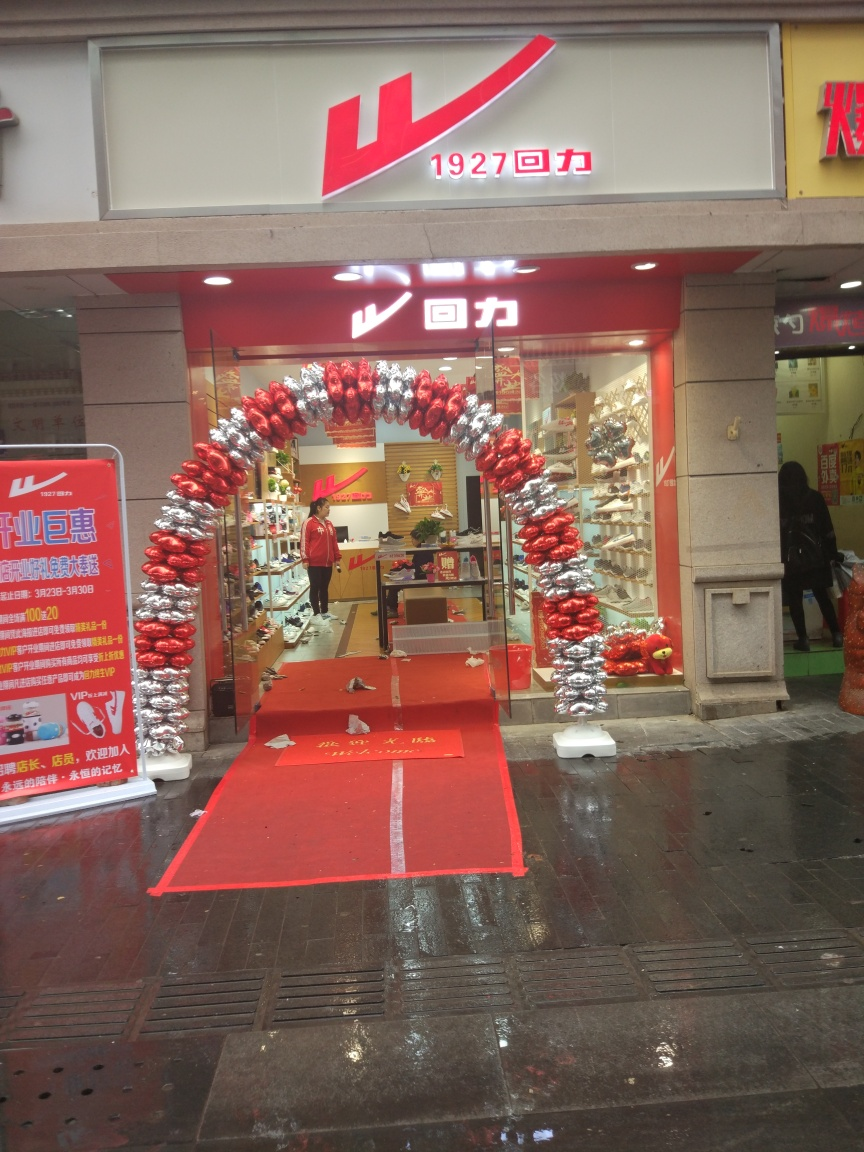Is the image quality of this photo not good? The image quality appears to be reasonable, with decent sharpness and clarity. However, there’s noticeable room for improvement concerning brightness and contrast levels, which could enhance the photo's visual appeal. 